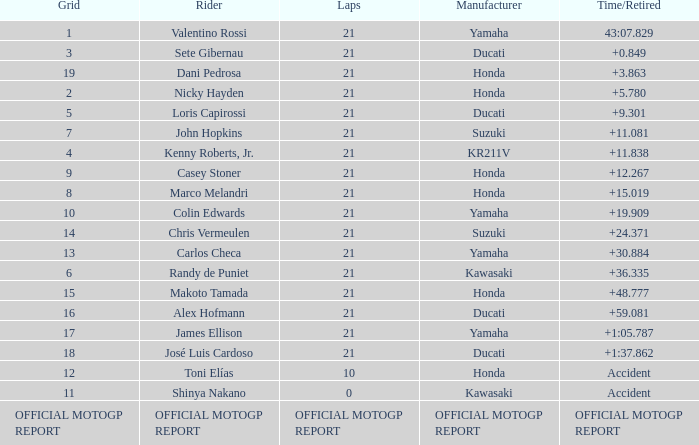WWhich rder had a vehicle manufactured by kr211v? Kenny Roberts, Jr. 